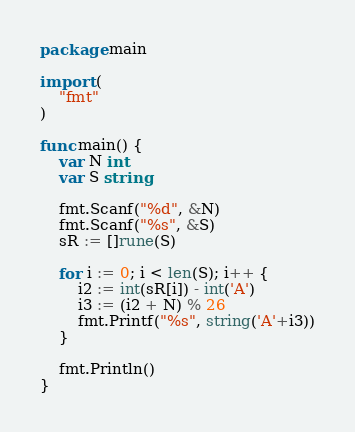Convert code to text. <code><loc_0><loc_0><loc_500><loc_500><_Go_>package main

import (
	"fmt"
)

func main() {
	var N int
	var S string

	fmt.Scanf("%d", &N)
	fmt.Scanf("%s", &S)
	sR := []rune(S)

	for i := 0; i < len(S); i++ {
		i2 := int(sR[i]) - int('A')
		i3 := (i2 + N) % 26
		fmt.Printf("%s", string('A'+i3))
	}

	fmt.Println()
}
</code> 